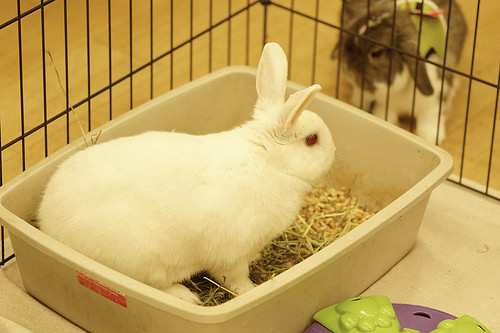<image>
Can you confirm if the cage is in the bunny? No. The cage is not contained within the bunny. These objects have a different spatial relationship. 